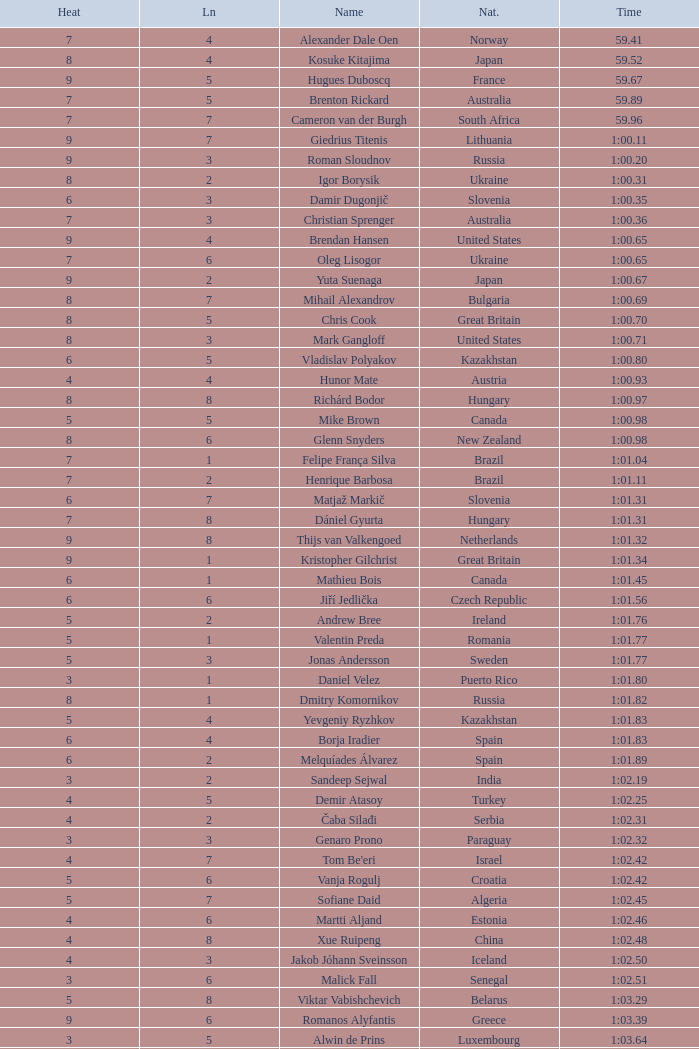I'm looking to parse the entire table for insights. Could you assist me with that? {'header': ['Heat', 'Ln', 'Name', 'Nat.', 'Time'], 'rows': [['7', '4', 'Alexander Dale Oen', 'Norway', '59.41'], ['8', '4', 'Kosuke Kitajima', 'Japan', '59.52'], ['9', '5', 'Hugues Duboscq', 'France', '59.67'], ['7', '5', 'Brenton Rickard', 'Australia', '59.89'], ['7', '7', 'Cameron van der Burgh', 'South Africa', '59.96'], ['9', '7', 'Giedrius Titenis', 'Lithuania', '1:00.11'], ['9', '3', 'Roman Sloudnov', 'Russia', '1:00.20'], ['8', '2', 'Igor Borysik', 'Ukraine', '1:00.31'], ['6', '3', 'Damir Dugonjič', 'Slovenia', '1:00.35'], ['7', '3', 'Christian Sprenger', 'Australia', '1:00.36'], ['9', '4', 'Brendan Hansen', 'United States', '1:00.65'], ['7', '6', 'Oleg Lisogor', 'Ukraine', '1:00.65'], ['9', '2', 'Yuta Suenaga', 'Japan', '1:00.67'], ['8', '7', 'Mihail Alexandrov', 'Bulgaria', '1:00.69'], ['8', '5', 'Chris Cook', 'Great Britain', '1:00.70'], ['8', '3', 'Mark Gangloff', 'United States', '1:00.71'], ['6', '5', 'Vladislav Polyakov', 'Kazakhstan', '1:00.80'], ['4', '4', 'Hunor Mate', 'Austria', '1:00.93'], ['8', '8', 'Richárd Bodor', 'Hungary', '1:00.97'], ['5', '5', 'Mike Brown', 'Canada', '1:00.98'], ['8', '6', 'Glenn Snyders', 'New Zealand', '1:00.98'], ['7', '1', 'Felipe França Silva', 'Brazil', '1:01.04'], ['7', '2', 'Henrique Barbosa', 'Brazil', '1:01.11'], ['6', '7', 'Matjaž Markič', 'Slovenia', '1:01.31'], ['7', '8', 'Dániel Gyurta', 'Hungary', '1:01.31'], ['9', '8', 'Thijs van Valkengoed', 'Netherlands', '1:01.32'], ['9', '1', 'Kristopher Gilchrist', 'Great Britain', '1:01.34'], ['6', '1', 'Mathieu Bois', 'Canada', '1:01.45'], ['6', '6', 'Jiří Jedlička', 'Czech Republic', '1:01.56'], ['5', '2', 'Andrew Bree', 'Ireland', '1:01.76'], ['5', '1', 'Valentin Preda', 'Romania', '1:01.77'], ['5', '3', 'Jonas Andersson', 'Sweden', '1:01.77'], ['3', '1', 'Daniel Velez', 'Puerto Rico', '1:01.80'], ['8', '1', 'Dmitry Komornikov', 'Russia', '1:01.82'], ['5', '4', 'Yevgeniy Ryzhkov', 'Kazakhstan', '1:01.83'], ['6', '4', 'Borja Iradier', 'Spain', '1:01.83'], ['6', '2', 'Melquíades Álvarez', 'Spain', '1:01.89'], ['3', '2', 'Sandeep Sejwal', 'India', '1:02.19'], ['4', '5', 'Demir Atasoy', 'Turkey', '1:02.25'], ['4', '2', 'Čaba Silađi', 'Serbia', '1:02.31'], ['3', '3', 'Genaro Prono', 'Paraguay', '1:02.32'], ['4', '7', "Tom Be'eri", 'Israel', '1:02.42'], ['5', '6', 'Vanja Rogulj', 'Croatia', '1:02.42'], ['5', '7', 'Sofiane Daid', 'Algeria', '1:02.45'], ['4', '6', 'Martti Aljand', 'Estonia', '1:02.46'], ['4', '8', 'Xue Ruipeng', 'China', '1:02.48'], ['4', '3', 'Jakob Jóhann Sveinsson', 'Iceland', '1:02.50'], ['3', '6', 'Malick Fall', 'Senegal', '1:02.51'], ['5', '8', 'Viktar Vabishchevich', 'Belarus', '1:03.29'], ['9', '6', 'Romanos Alyfantis', 'Greece', '1:03.39'], ['3', '5', 'Alwin de Prins', 'Luxembourg', '1:03.64'], ['3', '4', 'Sergio Andres Ferreyra', 'Argentina', '1:03.65'], ['2', '3', 'Edgar Crespo', 'Panama', '1:03.72'], ['2', '4', 'Sergiu Postica', 'Moldova', '1:03.83'], ['3', '8', 'Andrei Cross', 'Barbados', '1:04.57'], ['3', '7', 'Ivan Demyanenko', 'Uzbekistan', '1:05.14'], ['2', '6', 'Wael Koubrousli', 'Lebanon', '1:06.22'], ['2', '5', 'Nguyen Huu Viet', 'Vietnam', '1:06.36'], ['2', '2', 'Erik Rajohnson', 'Madagascar', '1:08.42'], ['2', '7', 'Boldbaataryn Bütekh-Uils', 'Mongolia', '1:10.80'], ['1', '4', 'Osama Mohammed Ye Alarag', 'Qatar', '1:10.83'], ['1', '5', 'Mohammed Al-Habsi', 'Oman', '1:12.28'], ['1', '3', 'Petero Okotai', 'Cook Islands', '1:20.20'], ['6', '8', 'Alessandro Terrin', 'Italy', 'DSQ'], ['4', '1', 'Mohammad Alirezaei', 'Iran', 'DNS']]} What is the smallest lane number of Xue Ruipeng? 8.0. 